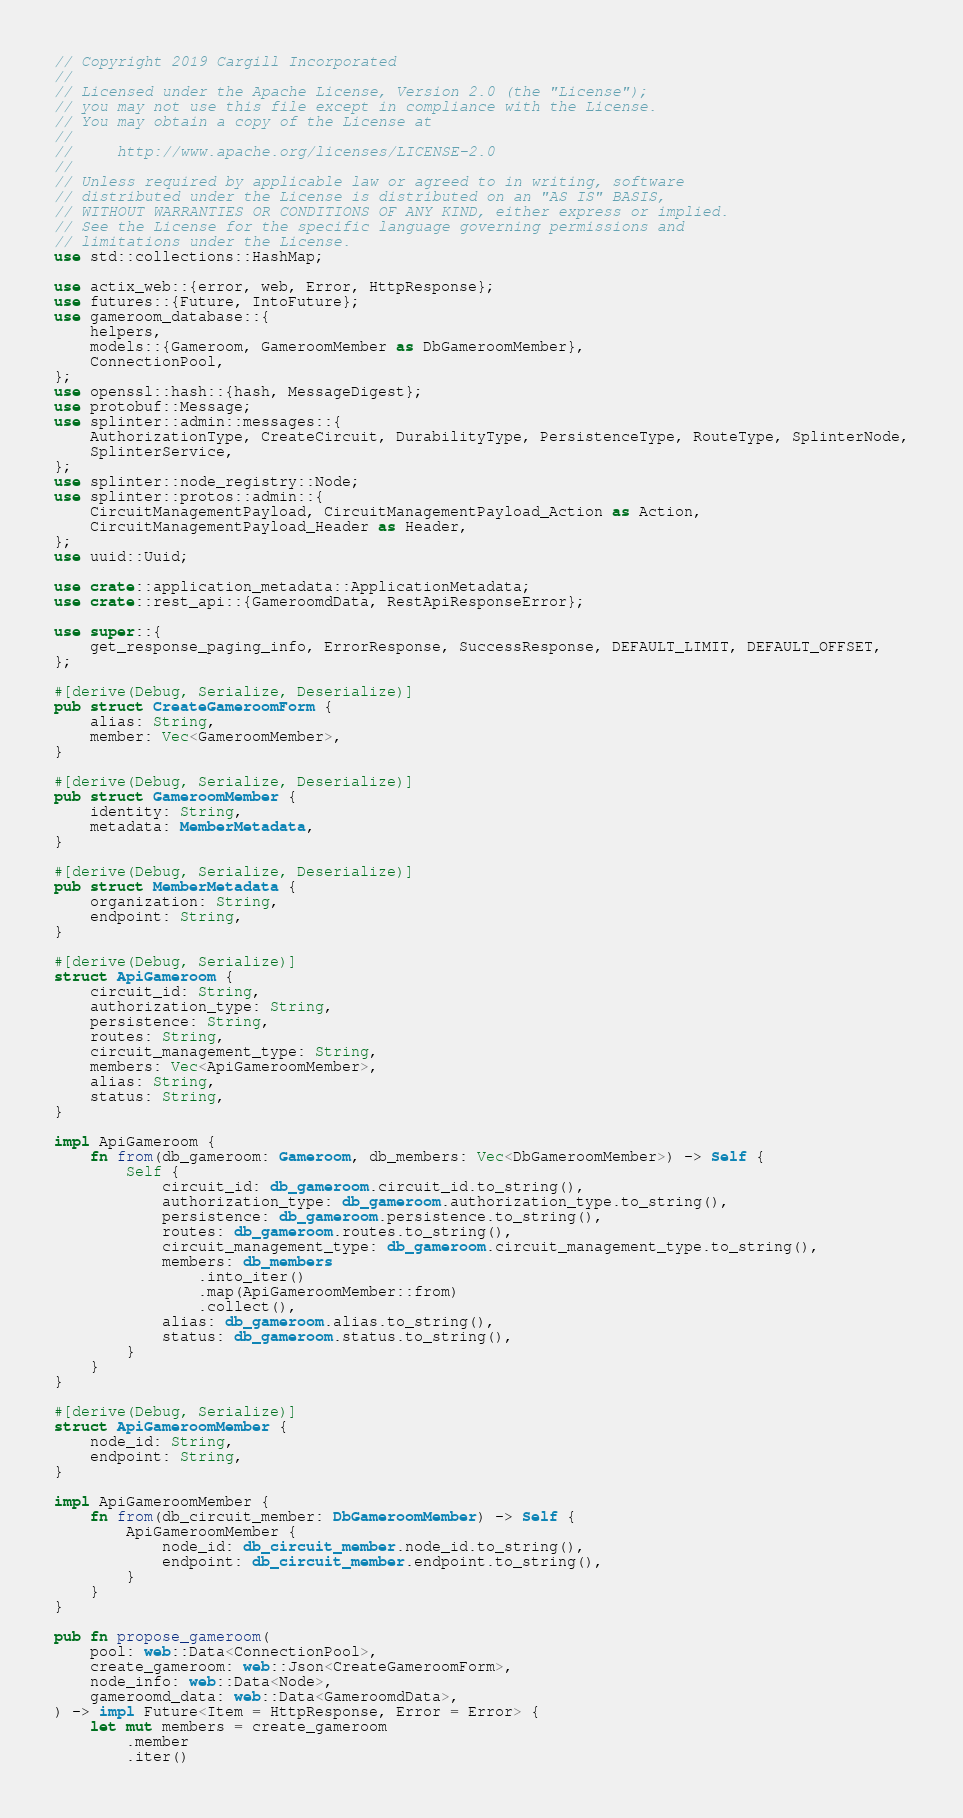<code> <loc_0><loc_0><loc_500><loc_500><_Rust_>// Copyright 2019 Cargill Incorporated
//
// Licensed under the Apache License, Version 2.0 (the "License");
// you may not use this file except in compliance with the License.
// You may obtain a copy of the License at
//
//     http://www.apache.org/licenses/LICENSE-2.0
//
// Unless required by applicable law or agreed to in writing, software
// distributed under the License is distributed on an "AS IS" BASIS,
// WITHOUT WARRANTIES OR CONDITIONS OF ANY KIND, either express or implied.
// See the License for the specific language governing permissions and
// limitations under the License.
use std::collections::HashMap;

use actix_web::{error, web, Error, HttpResponse};
use futures::{Future, IntoFuture};
use gameroom_database::{
    helpers,
    models::{Gameroom, GameroomMember as DbGameroomMember},
    ConnectionPool,
};
use openssl::hash::{hash, MessageDigest};
use protobuf::Message;
use splinter::admin::messages::{
    AuthorizationType, CreateCircuit, DurabilityType, PersistenceType, RouteType, SplinterNode,
    SplinterService,
};
use splinter::node_registry::Node;
use splinter::protos::admin::{
    CircuitManagementPayload, CircuitManagementPayload_Action as Action,
    CircuitManagementPayload_Header as Header,
};
use uuid::Uuid;

use crate::application_metadata::ApplicationMetadata;
use crate::rest_api::{GameroomdData, RestApiResponseError};

use super::{
    get_response_paging_info, ErrorResponse, SuccessResponse, DEFAULT_LIMIT, DEFAULT_OFFSET,
};

#[derive(Debug, Serialize, Deserialize)]
pub struct CreateGameroomForm {
    alias: String,
    member: Vec<GameroomMember>,
}

#[derive(Debug, Serialize, Deserialize)]
pub struct GameroomMember {
    identity: String,
    metadata: MemberMetadata,
}

#[derive(Debug, Serialize, Deserialize)]
pub struct MemberMetadata {
    organization: String,
    endpoint: String,
}

#[derive(Debug, Serialize)]
struct ApiGameroom {
    circuit_id: String,
    authorization_type: String,
    persistence: String,
    routes: String,
    circuit_management_type: String,
    members: Vec<ApiGameroomMember>,
    alias: String,
    status: String,
}

impl ApiGameroom {
    fn from(db_gameroom: Gameroom, db_members: Vec<DbGameroomMember>) -> Self {
        Self {
            circuit_id: db_gameroom.circuit_id.to_string(),
            authorization_type: db_gameroom.authorization_type.to_string(),
            persistence: db_gameroom.persistence.to_string(),
            routes: db_gameroom.routes.to_string(),
            circuit_management_type: db_gameroom.circuit_management_type.to_string(),
            members: db_members
                .into_iter()
                .map(ApiGameroomMember::from)
                .collect(),
            alias: db_gameroom.alias.to_string(),
            status: db_gameroom.status.to_string(),
        }
    }
}

#[derive(Debug, Serialize)]
struct ApiGameroomMember {
    node_id: String,
    endpoint: String,
}

impl ApiGameroomMember {
    fn from(db_circuit_member: DbGameroomMember) -> Self {
        ApiGameroomMember {
            node_id: db_circuit_member.node_id.to_string(),
            endpoint: db_circuit_member.endpoint.to_string(),
        }
    }
}

pub fn propose_gameroom(
    pool: web::Data<ConnectionPool>,
    create_gameroom: web::Json<CreateGameroomForm>,
    node_info: web::Data<Node>,
    gameroomd_data: web::Data<GameroomdData>,
) -> impl Future<Item = HttpResponse, Error = Error> {
    let mut members = create_gameroom
        .member
        .iter()</code> 